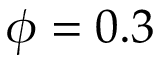<formula> <loc_0><loc_0><loc_500><loc_500>\phi = 0 . 3</formula> 